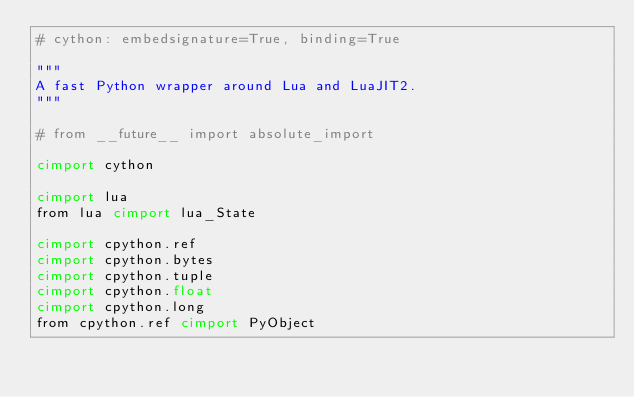<code> <loc_0><loc_0><loc_500><loc_500><_Cython_># cython: embedsignature=True, binding=True

"""
A fast Python wrapper around Lua and LuaJIT2.
"""

# from __future__ import absolute_import

cimport cython

cimport lua
from lua cimport lua_State

cimport cpython.ref
cimport cpython.bytes
cimport cpython.tuple
cimport cpython.float
cimport cpython.long
from cpython.ref cimport PyObject</code> 